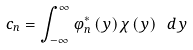<formula> <loc_0><loc_0><loc_500><loc_500>c _ { n } = \int _ { - \infty } ^ { \infty } \varphi _ { n } ^ { \ast } \left ( y \right ) \chi \left ( y \right ) \ d y</formula> 